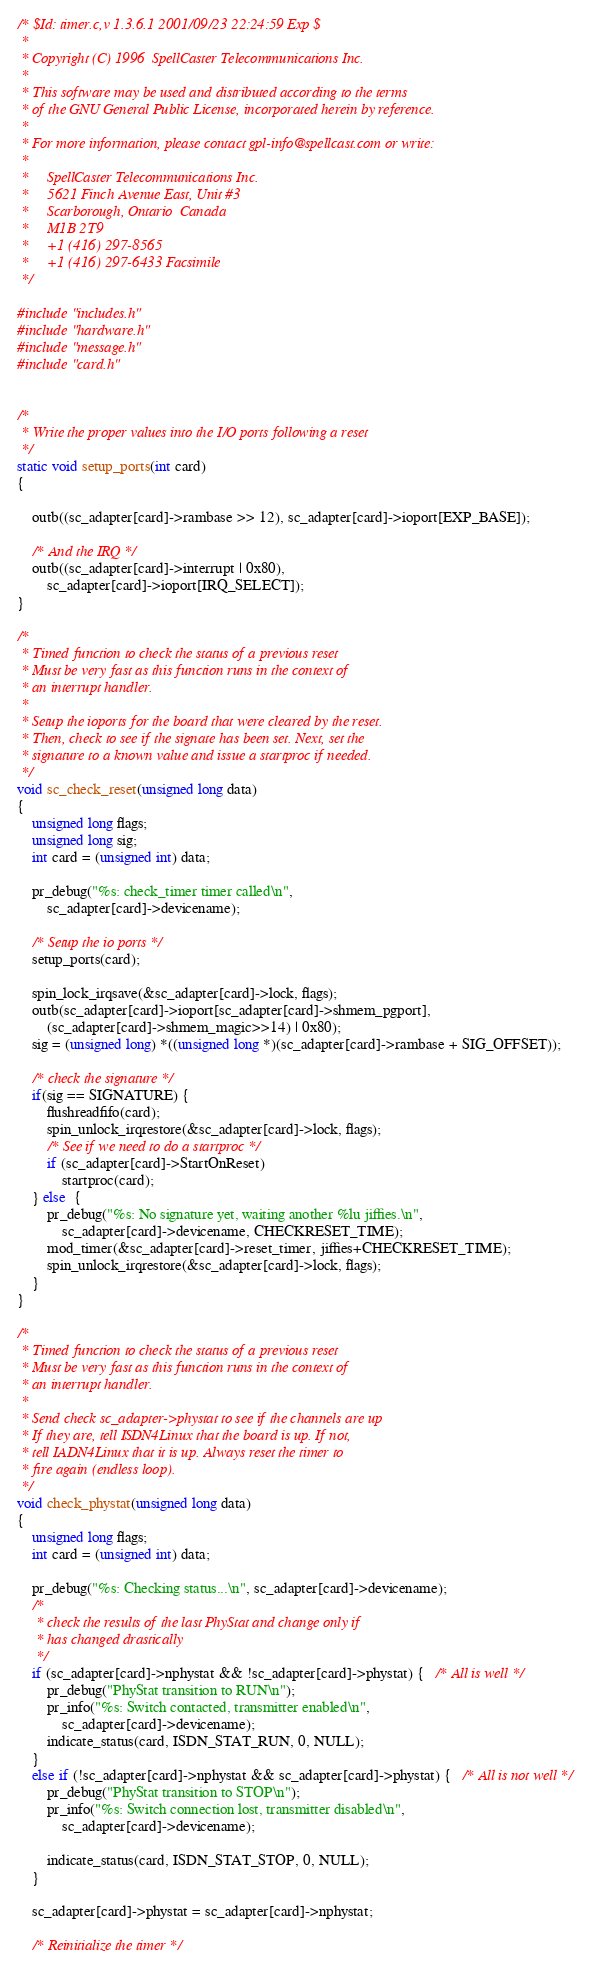<code> <loc_0><loc_0><loc_500><loc_500><_C_>/* $Id: timer.c,v 1.3.6.1 2001/09/23 22:24:59 Exp $
 *
 * Copyright (C) 1996  SpellCaster Telecommunications Inc.
 *
 * This software may be used and distributed according to the terms
 * of the GNU General Public License, incorporated herein by reference.
 *
 * For more information, please contact gpl-info@spellcast.com or write:
 *
 *     SpellCaster Telecommunications Inc.
 *     5621 Finch Avenue East, Unit #3
 *     Scarborough, Ontario  Canada
 *     M1B 2T9
 *     +1 (416) 297-8565
 *     +1 (416) 297-6433 Facsimile
 */

#include "includes.h"
#include "hardware.h"
#include "message.h"
#include "card.h"


/*
 * Write the proper values into the I/O ports following a reset
 */
static void setup_ports(int card)
{

	outb((sc_adapter[card]->rambase >> 12), sc_adapter[card]->ioport[EXP_BASE]);

	/* And the IRQ */
	outb((sc_adapter[card]->interrupt | 0x80),
		sc_adapter[card]->ioport[IRQ_SELECT]);
}

/*
 * Timed function to check the status of a previous reset
 * Must be very fast as this function runs in the context of
 * an interrupt handler.
 *
 * Setup the ioports for the board that were cleared by the reset.
 * Then, check to see if the signate has been set. Next, set the
 * signature to a known value and issue a startproc if needed.
 */
void sc_check_reset(unsigned long data)
{
	unsigned long flags;
	unsigned long sig;
	int card = (unsigned int) data;

	pr_debug("%s: check_timer timer called\n",
		sc_adapter[card]->devicename);

	/* Setup the io ports */
	setup_ports(card);

	spin_lock_irqsave(&sc_adapter[card]->lock, flags);
	outb(sc_adapter[card]->ioport[sc_adapter[card]->shmem_pgport],
		(sc_adapter[card]->shmem_magic>>14) | 0x80);
	sig = (unsigned long) *((unsigned long *)(sc_adapter[card]->rambase + SIG_OFFSET));

	/* check the signature */
	if(sig == SIGNATURE) {
		flushreadfifo(card);
		spin_unlock_irqrestore(&sc_adapter[card]->lock, flags);
		/* See if we need to do a startproc */
		if (sc_adapter[card]->StartOnReset)
			startproc(card);
	} else  {
		pr_debug("%s: No signature yet, waiting another %lu jiffies.\n",
			sc_adapter[card]->devicename, CHECKRESET_TIME);
		mod_timer(&sc_adapter[card]->reset_timer, jiffies+CHECKRESET_TIME);
		spin_unlock_irqrestore(&sc_adapter[card]->lock, flags);
	}
}

/*
 * Timed function to check the status of a previous reset
 * Must be very fast as this function runs in the context of
 * an interrupt handler.
 *
 * Send check sc_adapter->phystat to see if the channels are up
 * If they are, tell ISDN4Linux that the board is up. If not,
 * tell IADN4Linux that it is up. Always reset the timer to
 * fire again (endless loop).
 */
void check_phystat(unsigned long data)
{
	unsigned long flags;
	int card = (unsigned int) data;

	pr_debug("%s: Checking status...\n", sc_adapter[card]->devicename);
	/* 
	 * check the results of the last PhyStat and change only if
	 * has changed drastically
	 */
	if (sc_adapter[card]->nphystat && !sc_adapter[card]->phystat) {   /* All is well */
		pr_debug("PhyStat transition to RUN\n");
		pr_info("%s: Switch contacted, transmitter enabled\n", 
			sc_adapter[card]->devicename);
		indicate_status(card, ISDN_STAT_RUN, 0, NULL);
	}
	else if (!sc_adapter[card]->nphystat && sc_adapter[card]->phystat) {   /* All is not well */
		pr_debug("PhyStat transition to STOP\n");
		pr_info("%s: Switch connection lost, transmitter disabled\n", 
			sc_adapter[card]->devicename);

		indicate_status(card, ISDN_STAT_STOP, 0, NULL);
	}

	sc_adapter[card]->phystat = sc_adapter[card]->nphystat;

	/* Reinitialize the timer */</code> 